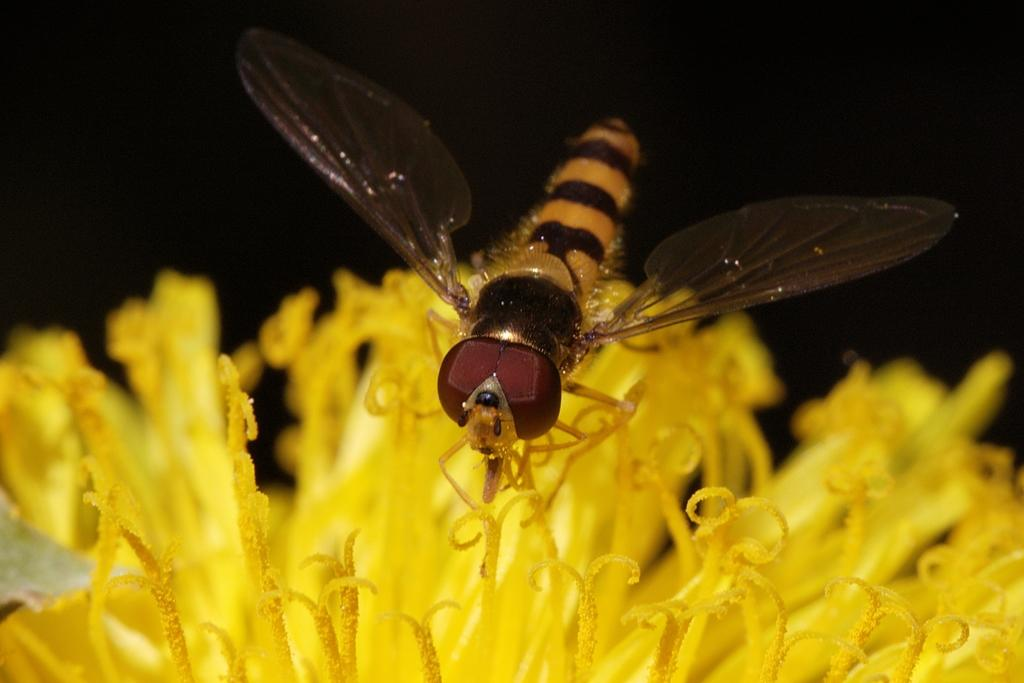What color can be seen on multiple objects in the image? There are yellow-colored things in the image. What type of insect is present in the image? There is an orange-colored insect in the image. Is there any specific marking or feature in the image? Yes, there is a black stripe in the image. What color is the background of the image? The background of the image is black. What type of apparatus can be seen on the hill in the image? There is no hill or apparatus present in the image. On which side of the image is the hill located? There is no hill in the image, so it cannot be located on any side. 